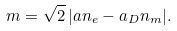Convert formula to latex. <formula><loc_0><loc_0><loc_500><loc_500>m = \sqrt { 2 } \, | a n _ { e } - a _ { D } n _ { m } | .</formula> 